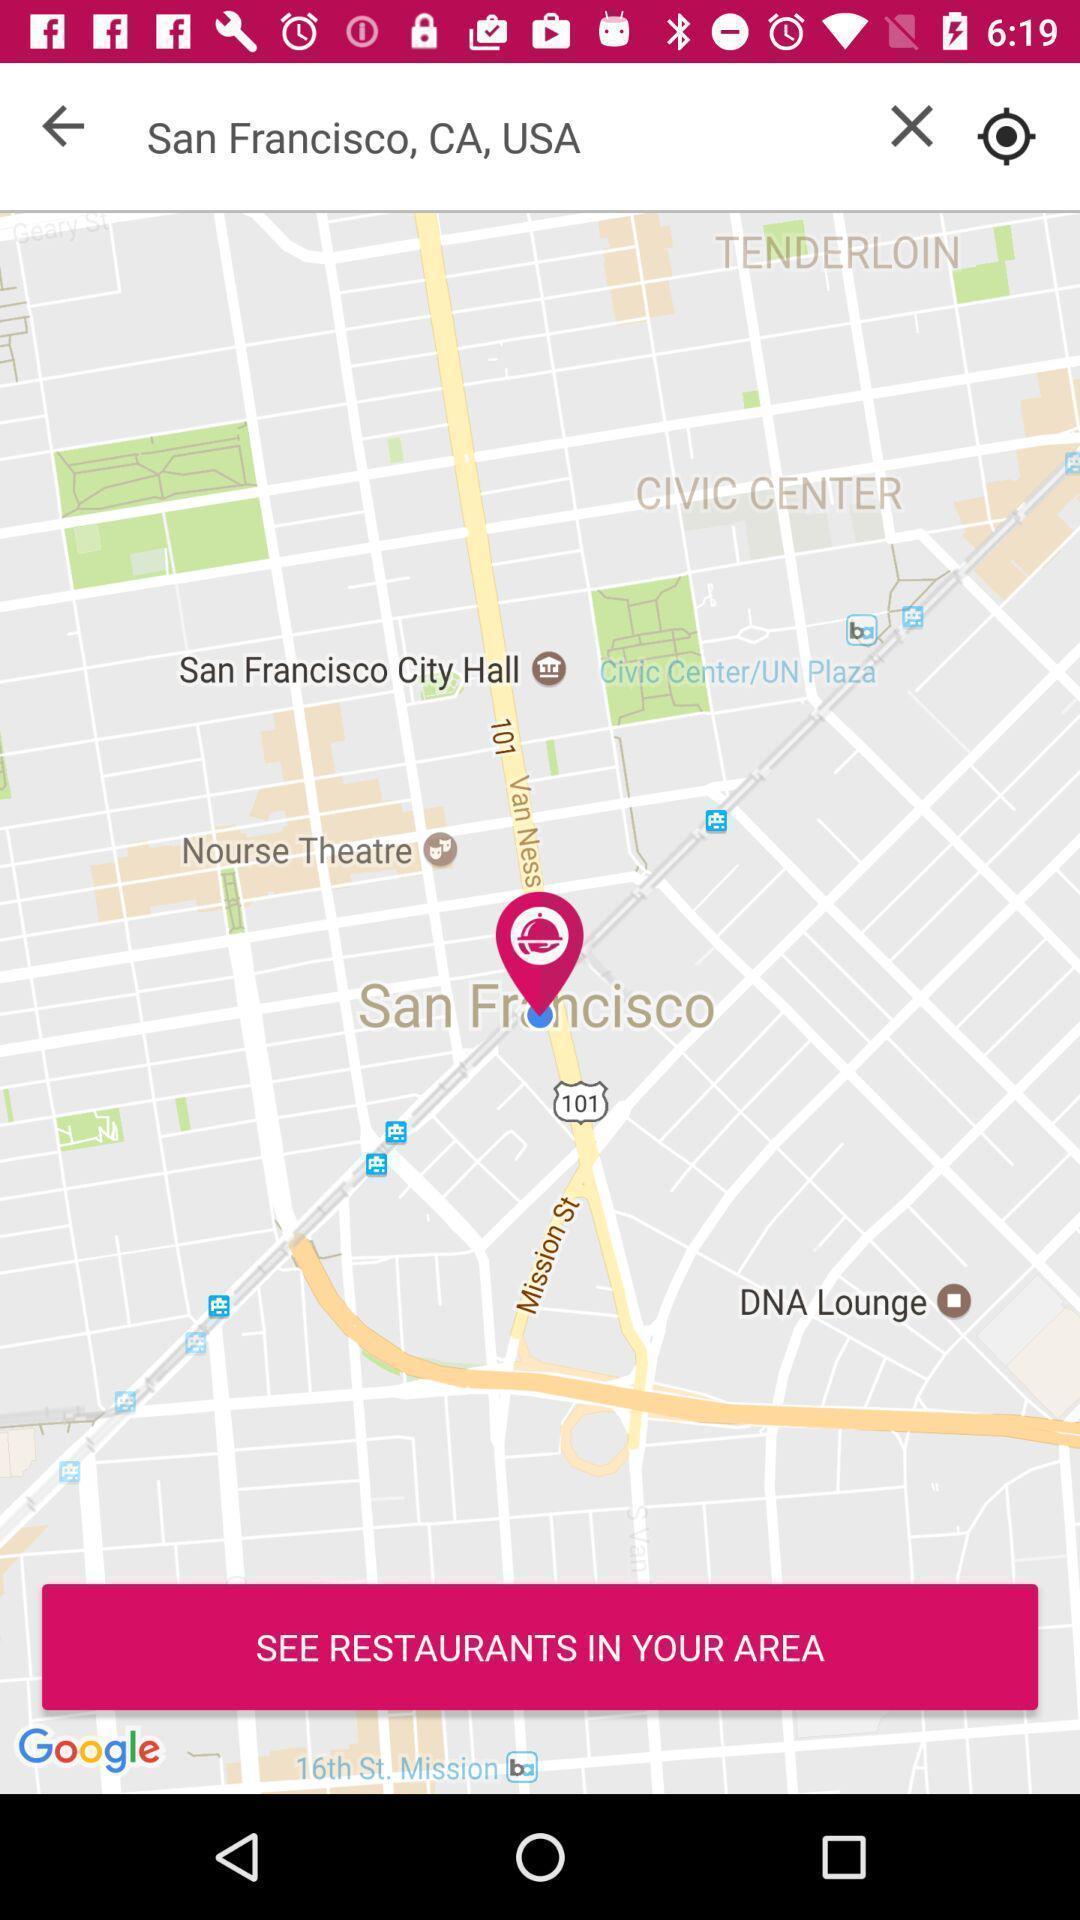Describe the content in this image. Screen displaying a map view of a particular location. 